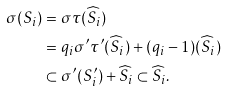<formula> <loc_0><loc_0><loc_500><loc_500>\sigma ( S _ { i } ) & = \sigma \tau ( \widehat { S } _ { i } ) \\ & = q _ { i } \sigma ^ { \prime } \tau ^ { \prime } ( \widehat { S } _ { i } ) + ( q _ { i } - 1 ) ( \widehat { S } _ { i } ) \\ & \subset \sigma ^ { \prime } ( S ^ { \prime } _ { i } ) + \widehat { S } _ { i } \subset \widehat { S } _ { i } .</formula> 